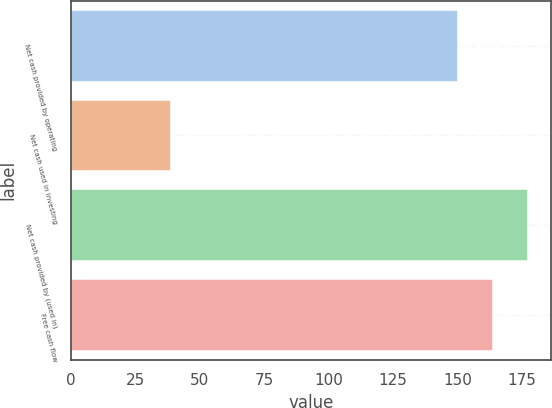Convert chart to OTSL. <chart><loc_0><loc_0><loc_500><loc_500><bar_chart><fcel>Net cash provided by operating<fcel>Net cash used in investing<fcel>Net cash provided by (used in)<fcel>Free cash flow<nl><fcel>150<fcel>38.8<fcel>177.52<fcel>163.76<nl></chart> 